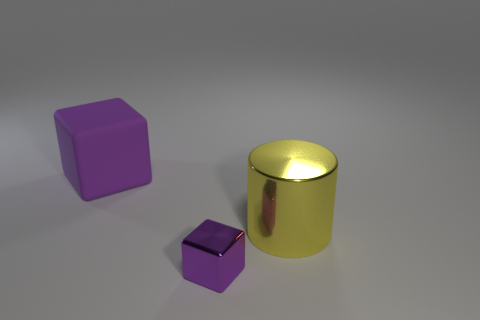Can you describe the shadows cast by the objects and what they tell us about the light source? The shadows are soft-edged and extend to the right of the objects, indicating that the light source is to the left. The length and angle of the shadows suggest the light source is relatively close to the objects, positioned above and to the side. 